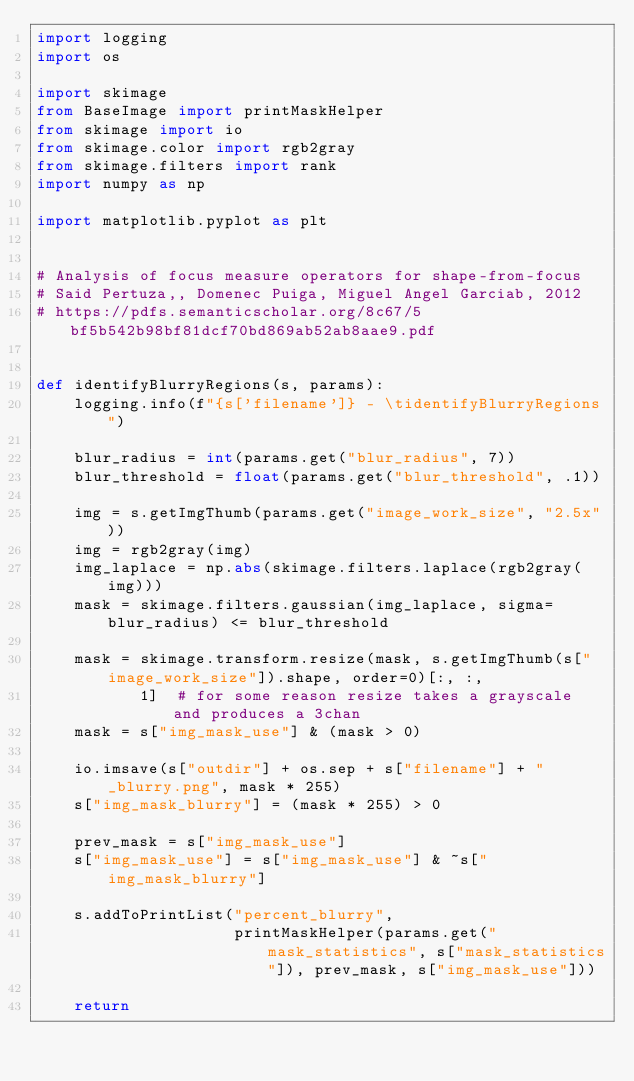<code> <loc_0><loc_0><loc_500><loc_500><_Python_>import logging
import os

import skimage
from BaseImage import printMaskHelper
from skimage import io
from skimage.color import rgb2gray
from skimage.filters import rank
import numpy as np

import matplotlib.pyplot as plt


# Analysis of focus measure operators for shape-from-focus
# Said Pertuza,, Domenec Puiga, Miguel Angel Garciab, 2012
# https://pdfs.semanticscholar.org/8c67/5bf5b542b98bf81dcf70bd869ab52ab8aae9.pdf


def identifyBlurryRegions(s, params):
    logging.info(f"{s['filename']} - \tidentifyBlurryRegions")

    blur_radius = int(params.get("blur_radius", 7))
    blur_threshold = float(params.get("blur_threshold", .1))

    img = s.getImgThumb(params.get("image_work_size", "2.5x"))
    img = rgb2gray(img)
    img_laplace = np.abs(skimage.filters.laplace(rgb2gray(img)))
    mask = skimage.filters.gaussian(img_laplace, sigma=blur_radius) <= blur_threshold

    mask = skimage.transform.resize(mask, s.getImgThumb(s["image_work_size"]).shape, order=0)[:, :,
           1]  # for some reason resize takes a grayscale and produces a 3chan
    mask = s["img_mask_use"] & (mask > 0)

    io.imsave(s["outdir"] + os.sep + s["filename"] + "_blurry.png", mask * 255)
    s["img_mask_blurry"] = (mask * 255) > 0

    prev_mask = s["img_mask_use"]
    s["img_mask_use"] = s["img_mask_use"] & ~s["img_mask_blurry"]

    s.addToPrintList("percent_blurry",
                     printMaskHelper(params.get("mask_statistics", s["mask_statistics"]), prev_mask, s["img_mask_use"]))

    return
</code> 